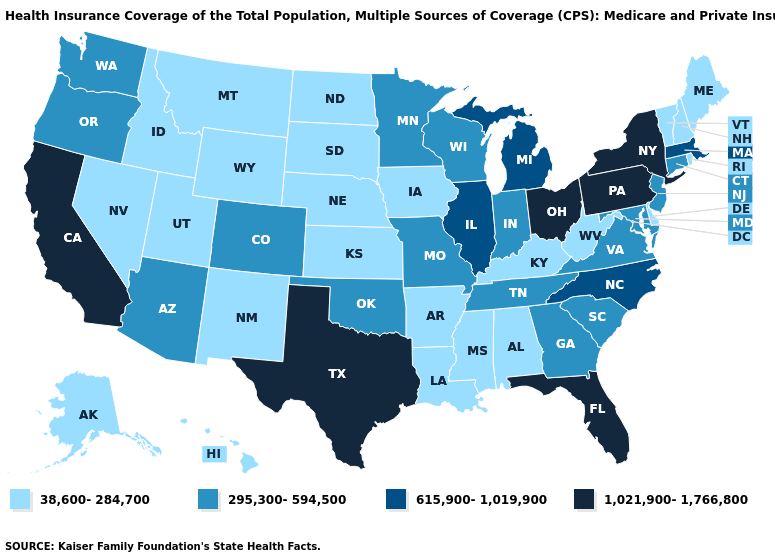Does the map have missing data?
Concise answer only. No. Name the states that have a value in the range 38,600-284,700?
Quick response, please. Alabama, Alaska, Arkansas, Delaware, Hawaii, Idaho, Iowa, Kansas, Kentucky, Louisiana, Maine, Mississippi, Montana, Nebraska, Nevada, New Hampshire, New Mexico, North Dakota, Rhode Island, South Dakota, Utah, Vermont, West Virginia, Wyoming. Among the states that border Kansas , which have the lowest value?
Write a very short answer. Nebraska. How many symbols are there in the legend?
Keep it brief. 4. Does Kentucky have a higher value than Massachusetts?
Answer briefly. No. What is the highest value in the USA?
Short answer required. 1,021,900-1,766,800. What is the value of New York?
Short answer required. 1,021,900-1,766,800. What is the lowest value in the West?
Keep it brief. 38,600-284,700. What is the value of Delaware?
Be succinct. 38,600-284,700. Which states have the highest value in the USA?
Be succinct. California, Florida, New York, Ohio, Pennsylvania, Texas. How many symbols are there in the legend?
Concise answer only. 4. How many symbols are there in the legend?
Short answer required. 4. Among the states that border California , does Oregon have the lowest value?
Give a very brief answer. No. Which states hav the highest value in the West?
Keep it brief. California. 